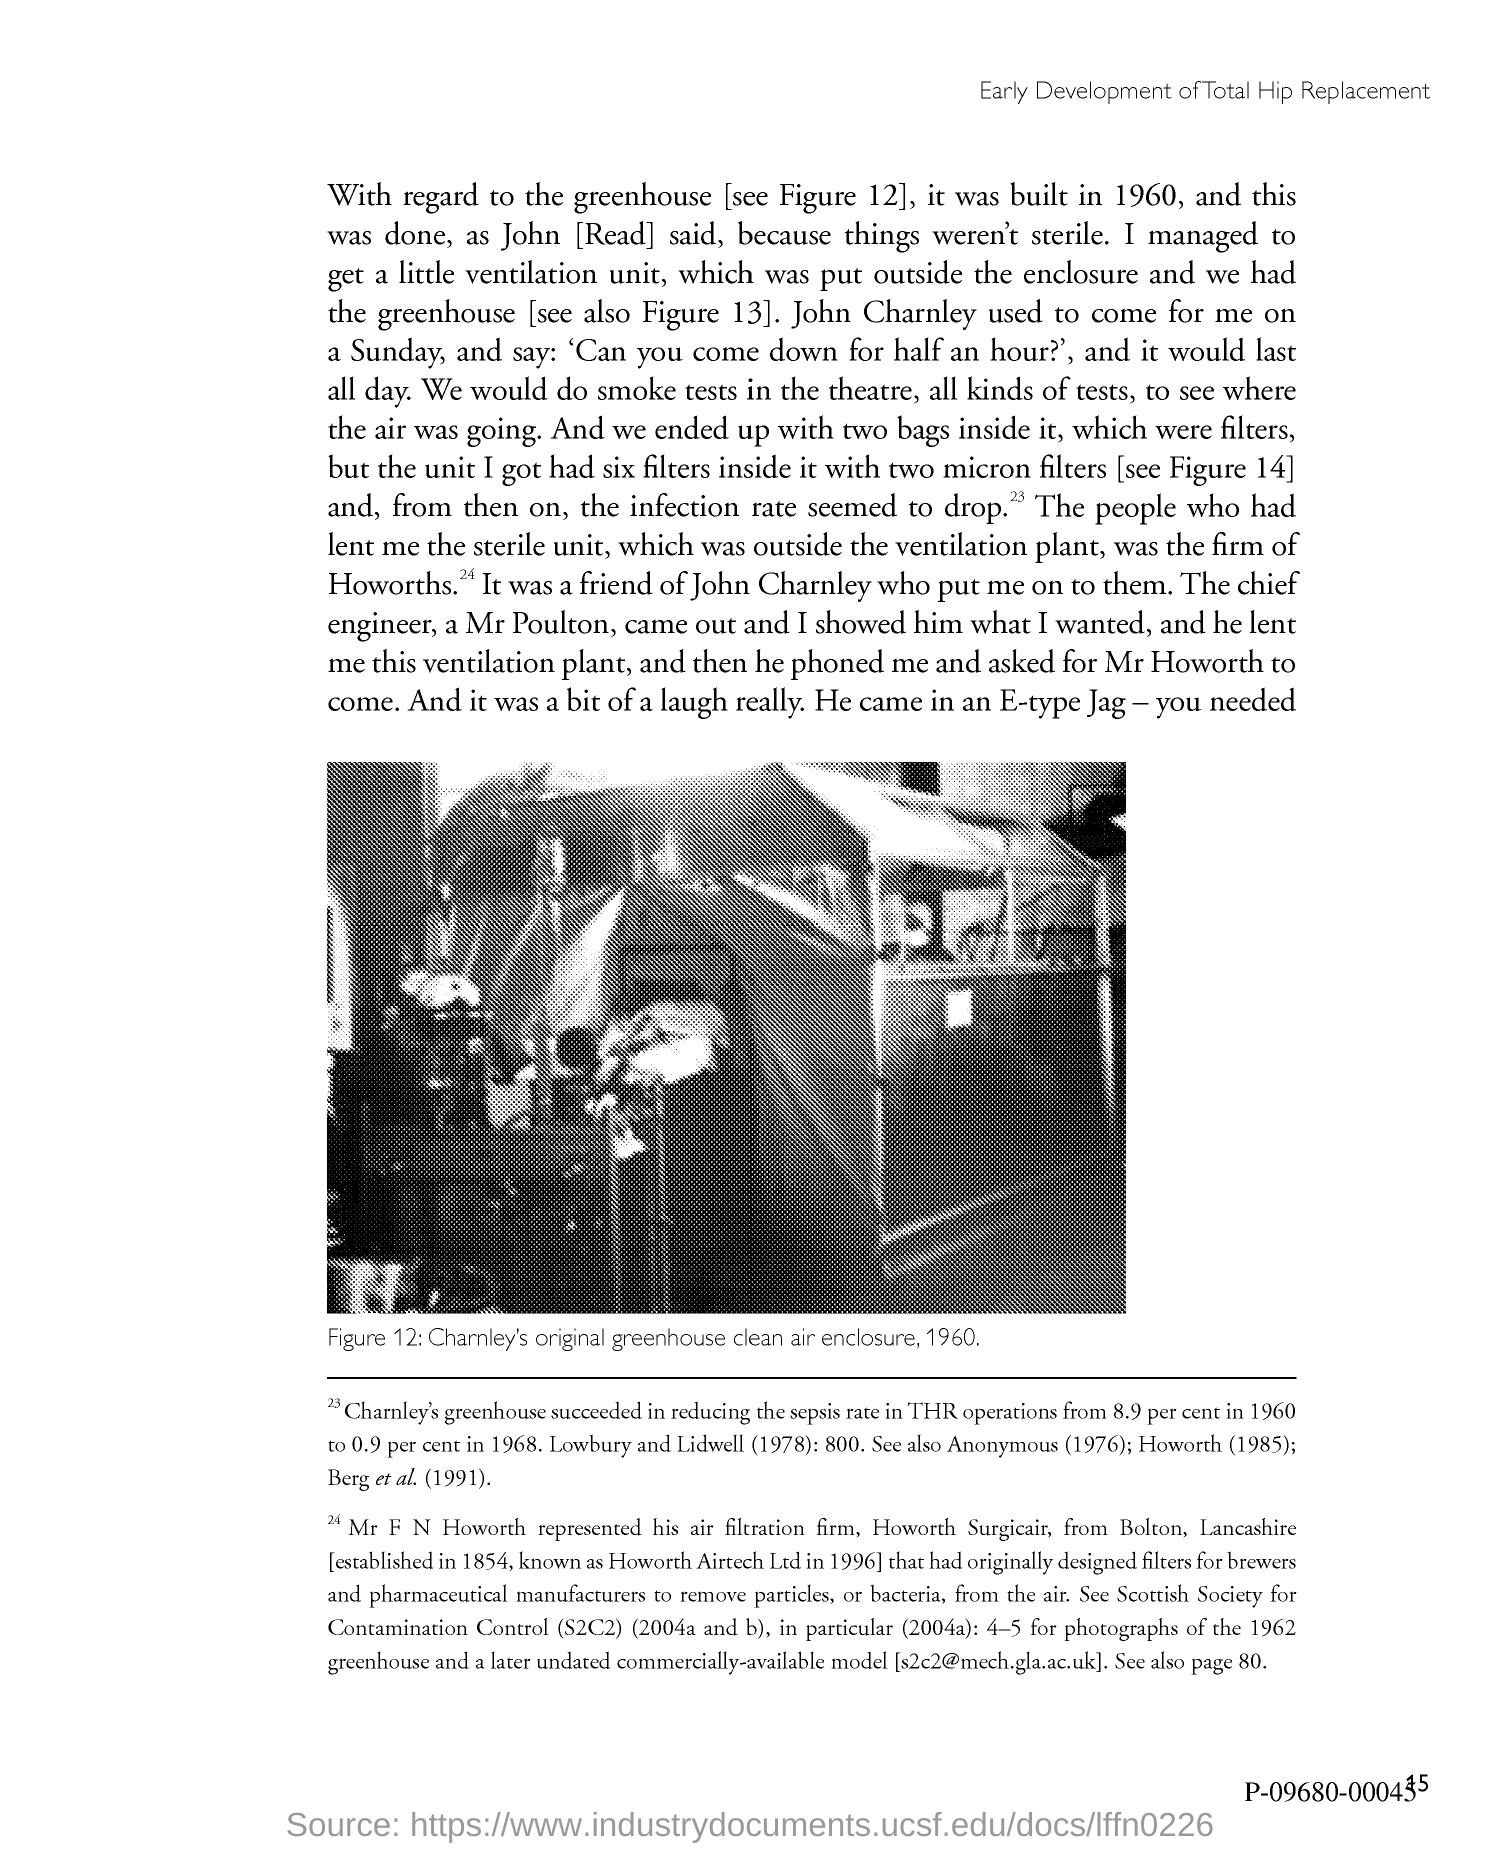What does Figure 12 in this document show?
Give a very brief answer. CHARNLEY'S ORIGINAL GREENHOUSE CLEAN AIR ENCLOSURE , 1960. 